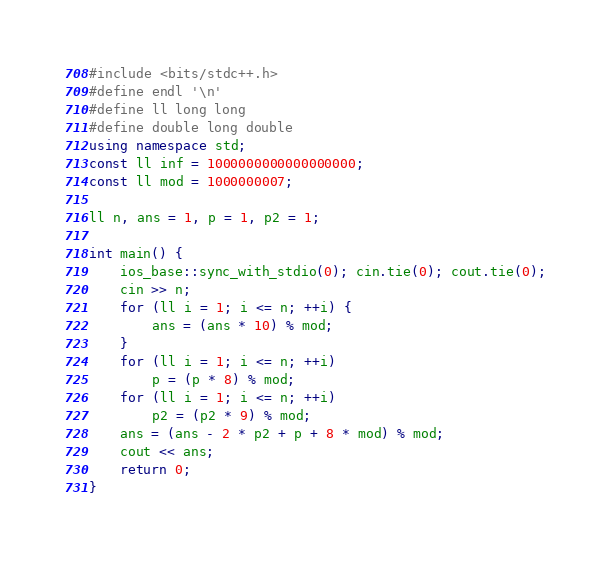Convert code to text. <code><loc_0><loc_0><loc_500><loc_500><_C++_>#include <bits/stdc++.h>
#define endl '\n'
#define ll long long
#define double long double
using namespace std;
const ll inf = 1000000000000000000;
const ll mod = 1000000007;

ll n, ans = 1, p = 1, p2 = 1;

int main() {
    ios_base::sync_with_stdio(0); cin.tie(0); cout.tie(0);
    cin >> n;
    for (ll i = 1; i <= n; ++i) {
        ans = (ans * 10) % mod;
    }
    for (ll i = 1; i <= n; ++i)
        p = (p * 8) % mod;
    for (ll i = 1; i <= n; ++i)
        p2 = (p2 * 9) % mod;
    ans = (ans - 2 * p2 + p + 8 * mod) % mod;
    cout << ans;
    return 0;
}
</code> 